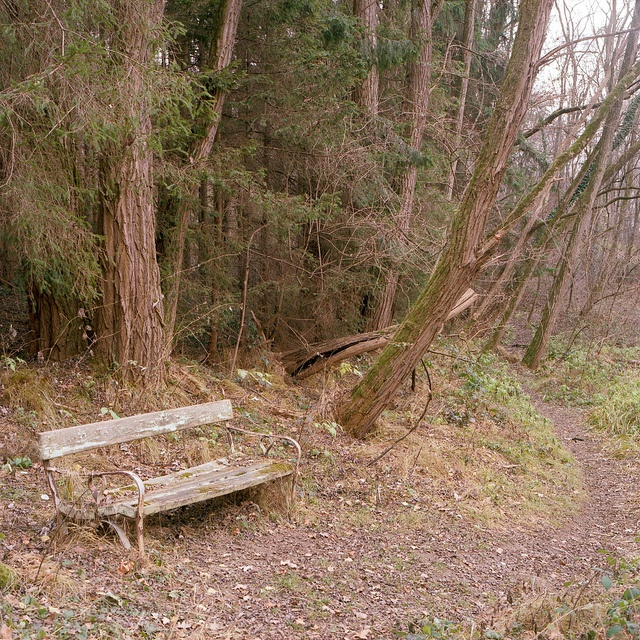Describe the objects in this image and their specific colors. I can see a bench in olive, tan, gray, and darkgray tones in this image. 